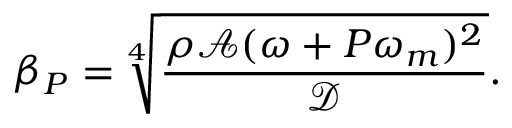<formula> <loc_0><loc_0><loc_500><loc_500>\beta _ { P } = \sqrt { [ } 4 ] { \frac { \rho \mathcal { A } ( \omega + P \omega _ { m } ) ^ { 2 } } { \mathcal { D } } } .</formula> 